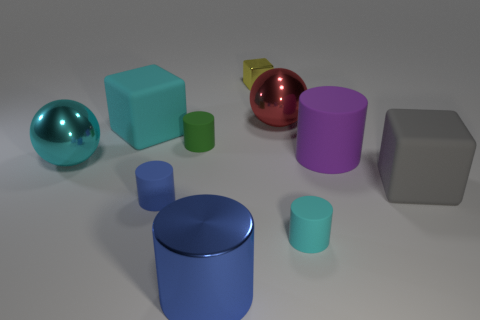The other block that is the same size as the gray block is what color? The block sharing the same size attributes as the gray block has a calming shade of cyan, reminiscent of a clear sky on a sunny day. 